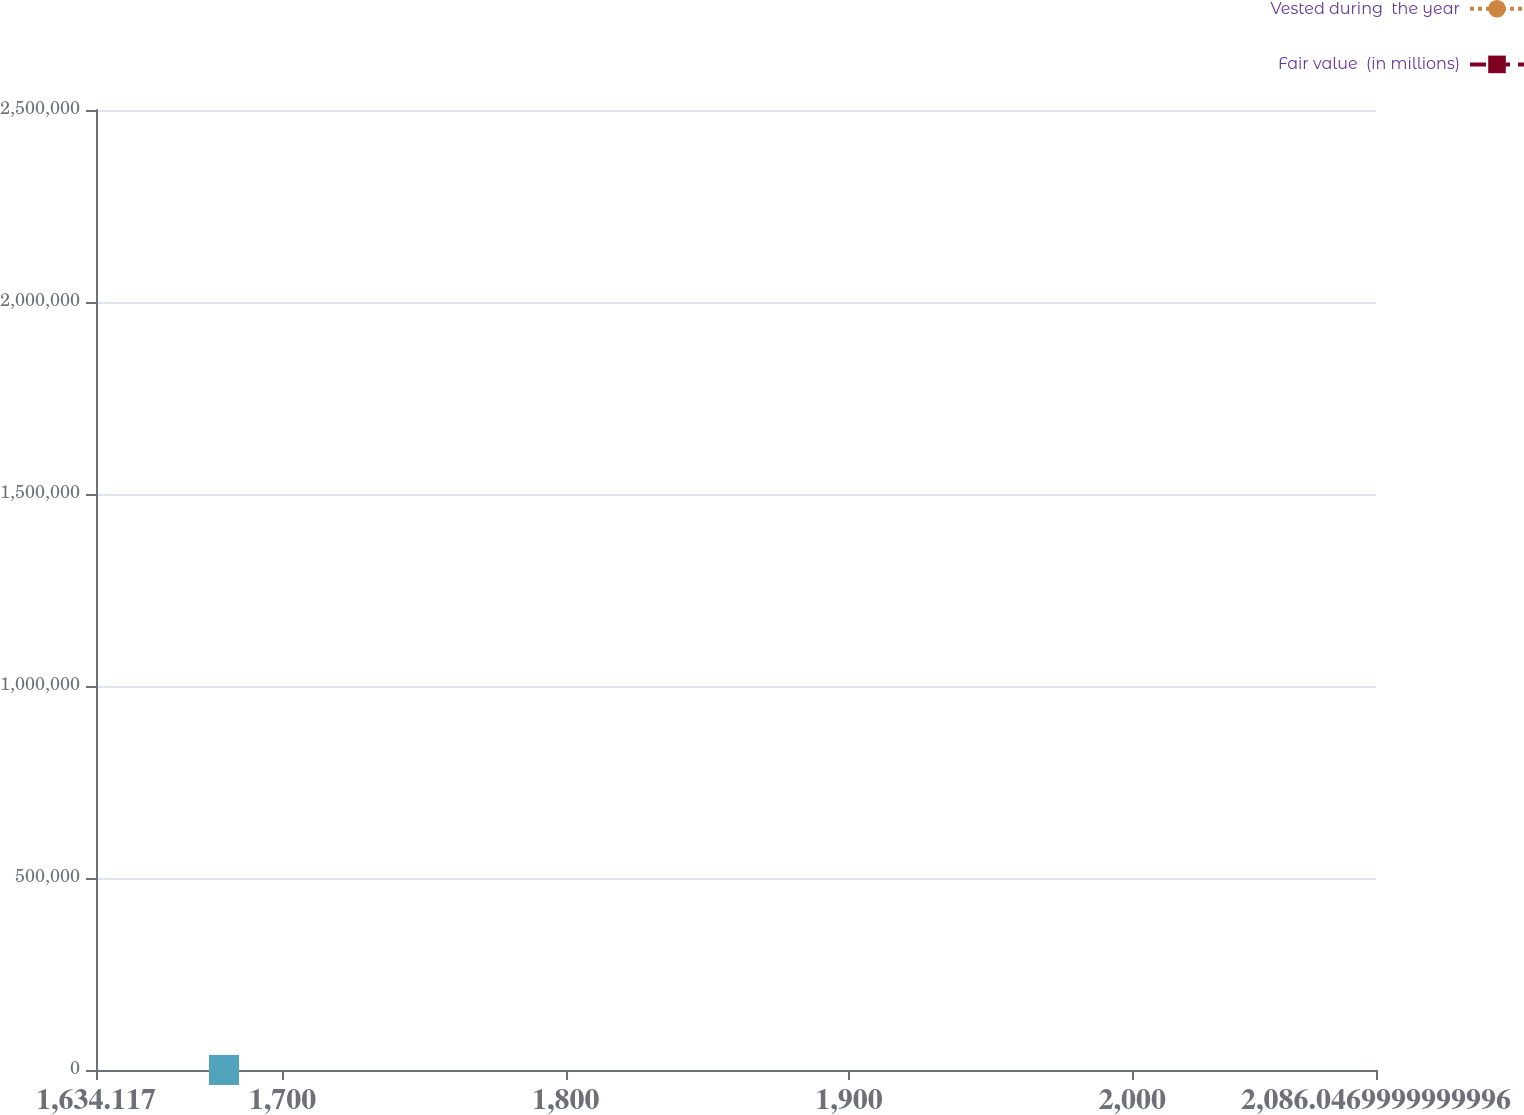Convert chart to OTSL. <chart><loc_0><loc_0><loc_500><loc_500><line_chart><ecel><fcel>Vested during  the year<fcel>Fair value  (in millions)<nl><fcel>1679.31<fcel>2.49735e+06<fcel>116.05<nl><fcel>2086.45<fcel>2.60772e+06<fcel>113.69<nl><fcel>2131.24<fcel>2.76078e+06<fcel>109.52<nl></chart> 